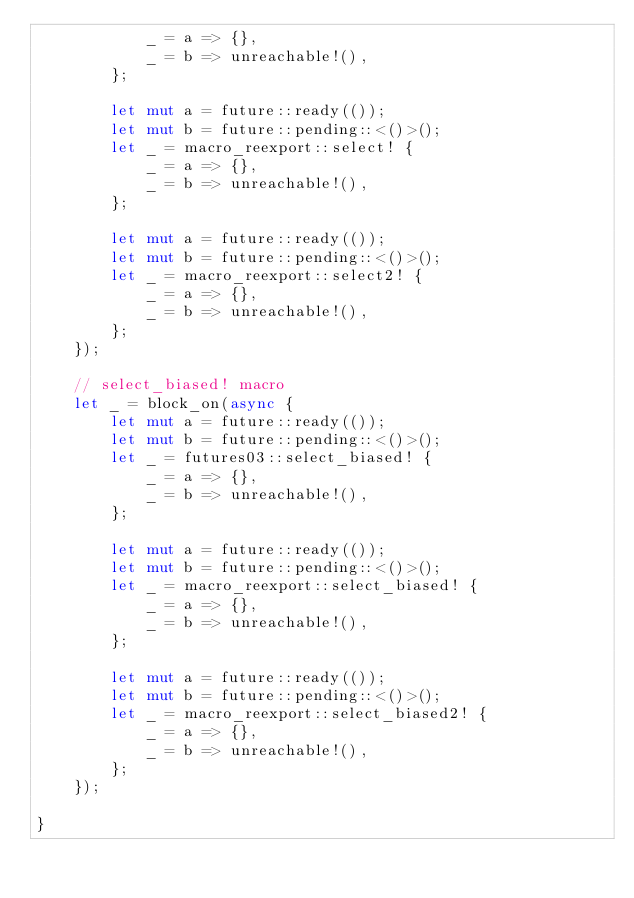<code> <loc_0><loc_0><loc_500><loc_500><_Rust_>            _ = a => {},
            _ = b => unreachable!(),
        };

        let mut a = future::ready(());
        let mut b = future::pending::<()>();
        let _ = macro_reexport::select! {
            _ = a => {},
            _ = b => unreachable!(),
        };

        let mut a = future::ready(());
        let mut b = future::pending::<()>();
        let _ = macro_reexport::select2! {
            _ = a => {},
            _ = b => unreachable!(),
        };
    });

    // select_biased! macro
    let _ = block_on(async {
        let mut a = future::ready(());
        let mut b = future::pending::<()>();
        let _ = futures03::select_biased! {
            _ = a => {},
            _ = b => unreachable!(),
        };

        let mut a = future::ready(());
        let mut b = future::pending::<()>();
        let _ = macro_reexport::select_biased! {
            _ = a => {},
            _ = b => unreachable!(),
        };

        let mut a = future::ready(());
        let mut b = future::pending::<()>();
        let _ = macro_reexport::select_biased2! {
            _ = a => {},
            _ = b => unreachable!(),
        };
    });

}
</code> 